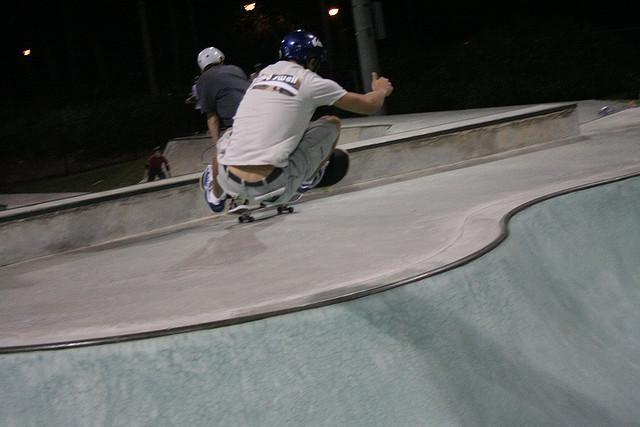World skate is the head controller of which game?
Answer the question by selecting the correct answer among the 4 following choices.
Options: Kiting, swimming, skating, snowboarding. Skating. 